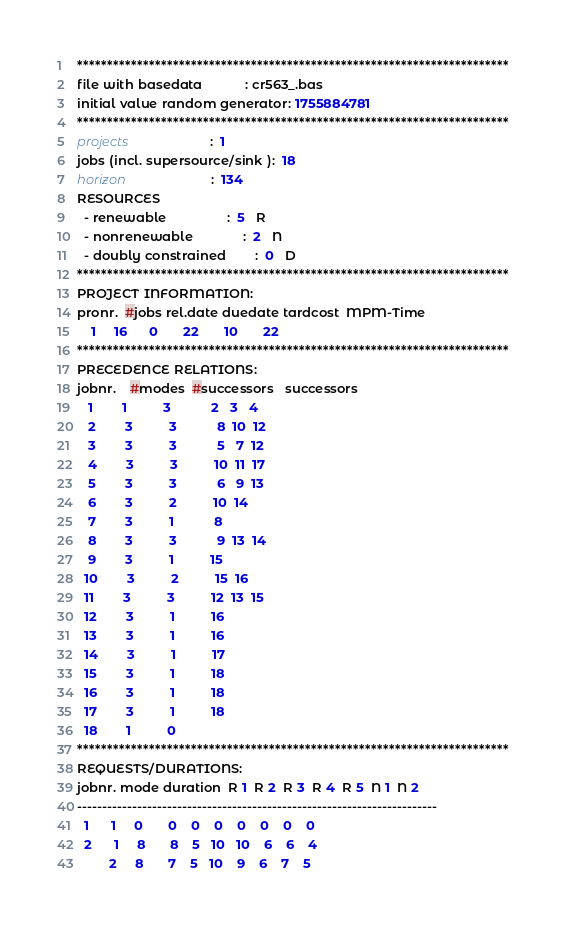Convert code to text. <code><loc_0><loc_0><loc_500><loc_500><_ObjectiveC_>************************************************************************
file with basedata            : cr563_.bas
initial value random generator: 1755884781
************************************************************************
projects                      :  1
jobs (incl. supersource/sink ):  18
horizon                       :  134
RESOURCES
  - renewable                 :  5   R
  - nonrenewable              :  2   N
  - doubly constrained        :  0   D
************************************************************************
PROJECT INFORMATION:
pronr.  #jobs rel.date duedate tardcost  MPM-Time
    1     16      0       22       10       22
************************************************************************
PRECEDENCE RELATIONS:
jobnr.    #modes  #successors   successors
   1        1          3           2   3   4
   2        3          3           8  10  12
   3        3          3           5   7  12
   4        3          3          10  11  17
   5        3          3           6   9  13
   6        3          2          10  14
   7        3          1           8
   8        3          3           9  13  14
   9        3          1          15
  10        3          2          15  16
  11        3          3          12  13  15
  12        3          1          16
  13        3          1          16
  14        3          1          17
  15        3          1          18
  16        3          1          18
  17        3          1          18
  18        1          0        
************************************************************************
REQUESTS/DURATIONS:
jobnr. mode duration  R 1  R 2  R 3  R 4  R 5  N 1  N 2
------------------------------------------------------------------------
  1      1     0       0    0    0    0    0    0    0
  2      1     8       8    5   10   10    6    6    4
         2     8       7    5   10    9    6    7    5</code> 